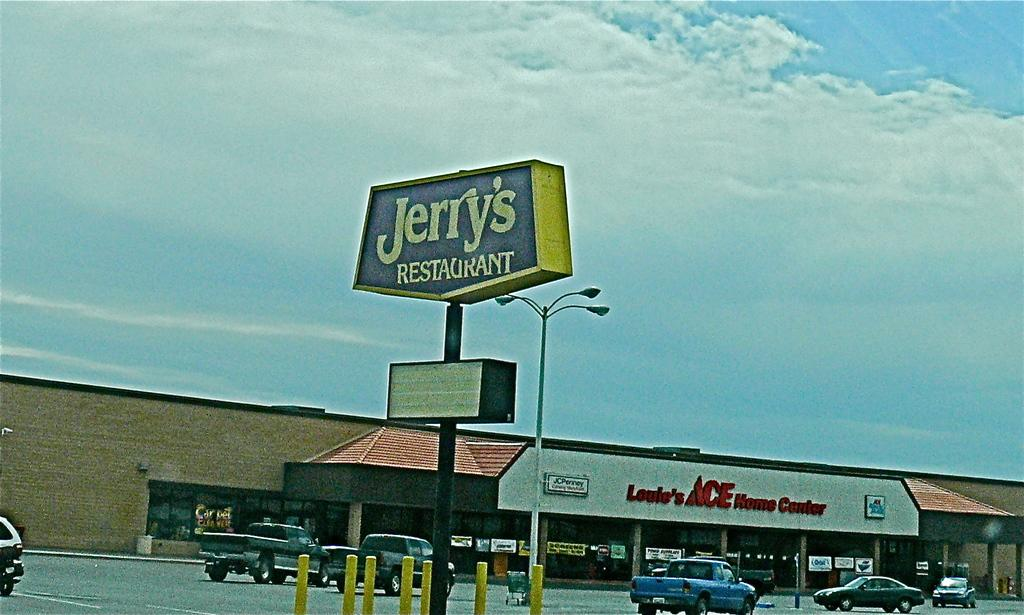<image>
Offer a succinct explanation of the picture presented. An old-looking photo of a Jerry's RESTAURANT sign with an ACE sign in the background. 